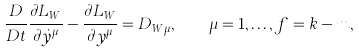<formula> <loc_0><loc_0><loc_500><loc_500>\frac { D } { D t } \frac { \partial L _ { W } } { \partial \dot { y } ^ { \mu } } - \frac { \partial L _ { W } } { \partial y ^ { \mu } } = D _ { W \mu } , \quad \mu = 1 , \dots , f = k - m ,</formula> 